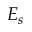Convert formula to latex. <formula><loc_0><loc_0><loc_500><loc_500>E _ { s }</formula> 